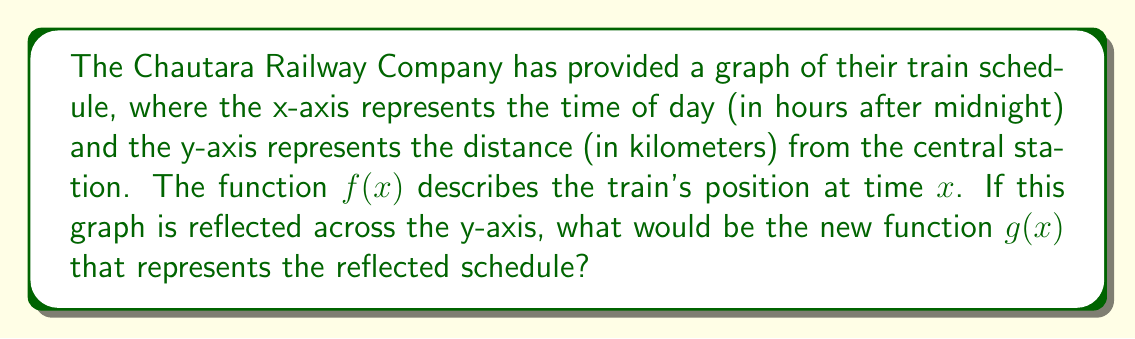Teach me how to tackle this problem. To find the reflection of the train schedule graph across the y-axis, we need to follow these steps:

1. Recall that a reflection across the y-axis changes the sign of the x-coordinate while keeping the y-coordinate the same.

2. The general form for reflecting a function $f(x)$ across the y-axis is:
   $g(x) = f(-x)$

3. This means that for any input $x$ in the new function $g(x)$, we use $-x$ as the input for the original function $f(x)$.

4. Intuitively, this reflection would reverse the time axis, making the train's journey appear to run backwards in time while maintaining the same distances from the central station.

5. Therefore, to obtain the new function $g(x)$ that represents the reflected schedule, we replace every $x$ in the original function $f(x)$ with $-x$.

6. The final step is to express this mathematically as:
   $g(x) = f(-x)$

This transformation effectively "flips" the graph horizontally around the y-axis, reversing the train's journey in time but keeping the distances unchanged.
Answer: $g(x) = f(-x)$ 